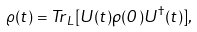Convert formula to latex. <formula><loc_0><loc_0><loc_500><loc_500>\varrho ( t ) = { T r } _ { L } [ U ( t ) \rho ( 0 ) U ^ { \dagger } ( t ) ] ,</formula> 